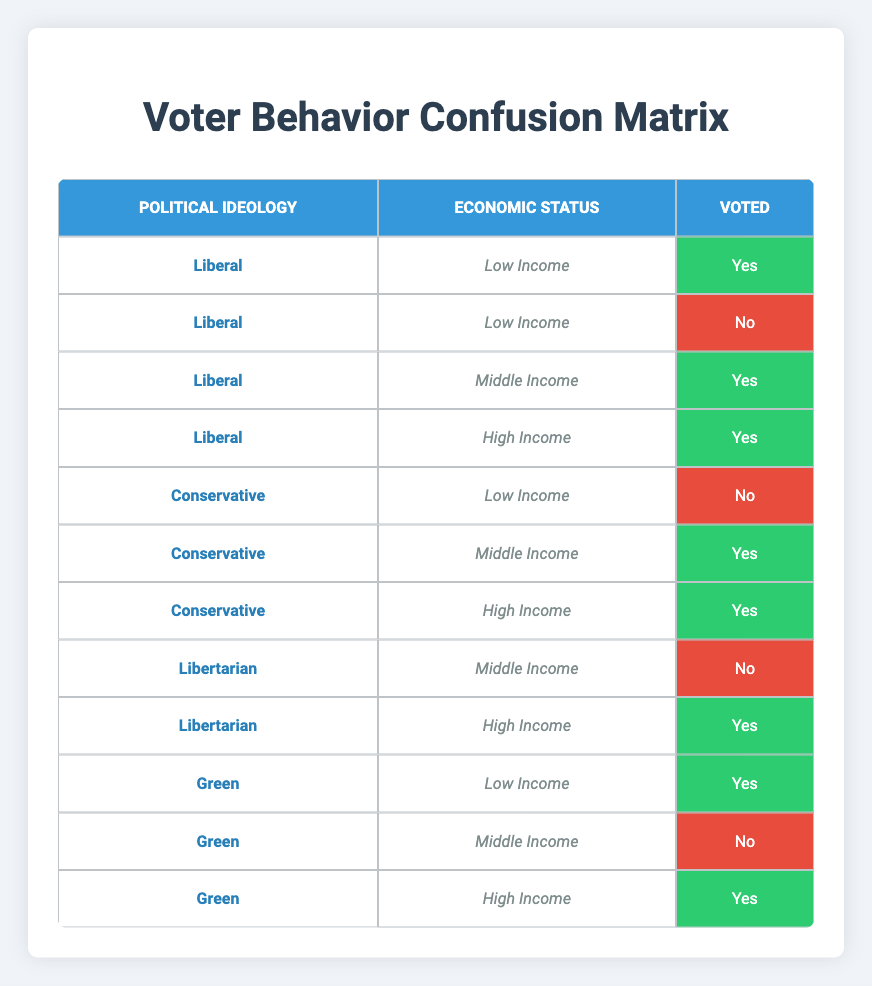What proportion of Liberal voters came from Low-Income households? There are two Liberal voters from Low-Income households: one voted Yes and one voted No. The total for Liberal voters in this category is 2. Therefore, the proportion is 2 out of the total voters from this grouping which includes additional Liberal income brackets as well. Given the total income range for Liberal is 4, the proportion can be calculated as 2/4 = 0.5 or 50%.
Answer: 50% How many Conservative voters voted Yes? From the table, there are two rows under Conservative where the voters voted Yes: one from Middle Income and one from High Income. By counting these two instances, we find the total count of Conservative voters who voted Yes is 2.
Answer: 2 Which political ideology had the highest number of Yes votes overall? By counting the Yes votes for each political ideology, we find: Liberal has 3 (from Middle and High Income + Low income Yes), Conservative has 2 (Middle and High), Libertarian has 1 (High Income), and Green has 2 (Low and High Income). The Liberal ideology has the highest total of Yes votes at 3, compared to others.
Answer: Liberal Is it true that all Middle Income voters voted? In the table, for Middle Income voters: Liberals voted Yes, Conservatives voted Yes, Libertarians voted No, and Greens voted No. Since there are two voters who did not vote in this economic bracket, it is false that all Middle Income voters voted.
Answer: No What is the total number of High Income voters who voted? In the table, the High Income category shows three voters: one Liberal (Yes), one Conservative (Yes), and one Libertarian (Yes), and lastly, one Green (Yes). Adding all these, the total number of High Income voters who voted is 4.
Answer: 4 Among the Low Income category, which ideology had more voters in total? In the Low Income category, Liberal had 2 voters (Yes and No) and Green had 1 voter (Yes), whereas Conservatives had 1 voter (No). By counting the totals: Liberal (2), Conservative (1), and Green (1). Hence, Liberals had the highest total voters in the Low Income category (2).
Answer: Liberal How many Libertarian voters voted Yes? From the data, there is only one instance of a Libertarian voter who voted Yes, which is from the High Income category. This direct count of yes votes leads us to conclude that the count is 1.
Answer: 1 What percentage of Green voters did not vote Yes? Green voters in the table consist of 3: Low Income (Yes), Middle Income (No), and High Income (Yes). Among these, only 1 voter did not vote Yes (the Middle Income). The percentage calculation will involve 1 from 3 total Green voters, which gives (1/3)*100 = 33.33%.
Answer: 33.33% 